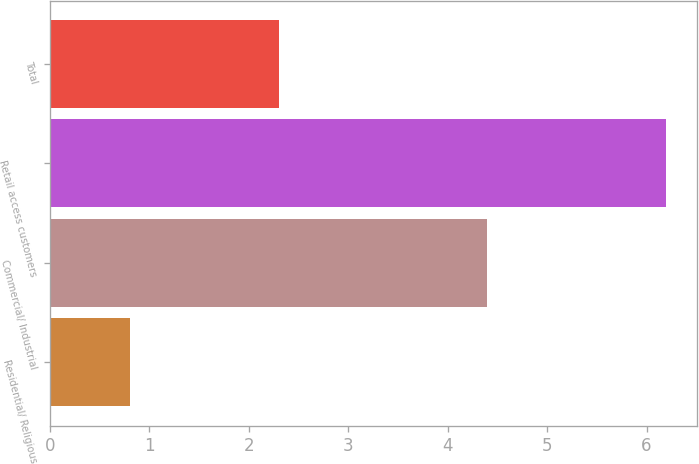Convert chart. <chart><loc_0><loc_0><loc_500><loc_500><bar_chart><fcel>Residential/ Religious<fcel>Commercial/ Industrial<fcel>Retail access customers<fcel>Total<nl><fcel>0.8<fcel>4.4<fcel>6.2<fcel>2.3<nl></chart> 